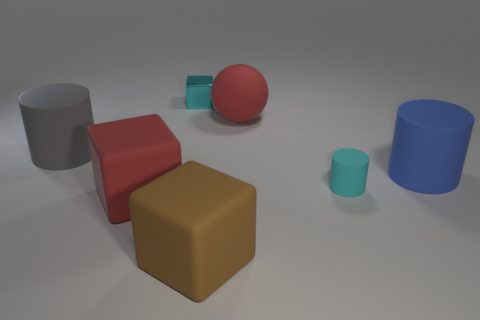Add 2 big purple metal cylinders. How many objects exist? 9 Subtract all large red rubber blocks. How many blocks are left? 2 Subtract all blocks. How many objects are left? 4 Subtract 2 cylinders. How many cylinders are left? 1 Add 3 red things. How many red things exist? 5 Subtract all gray cylinders. How many cylinders are left? 2 Subtract 1 red balls. How many objects are left? 6 Subtract all yellow cylinders. Subtract all purple blocks. How many cylinders are left? 3 Subtract all gray balls. How many brown blocks are left? 1 Subtract all large brown things. Subtract all cylinders. How many objects are left? 3 